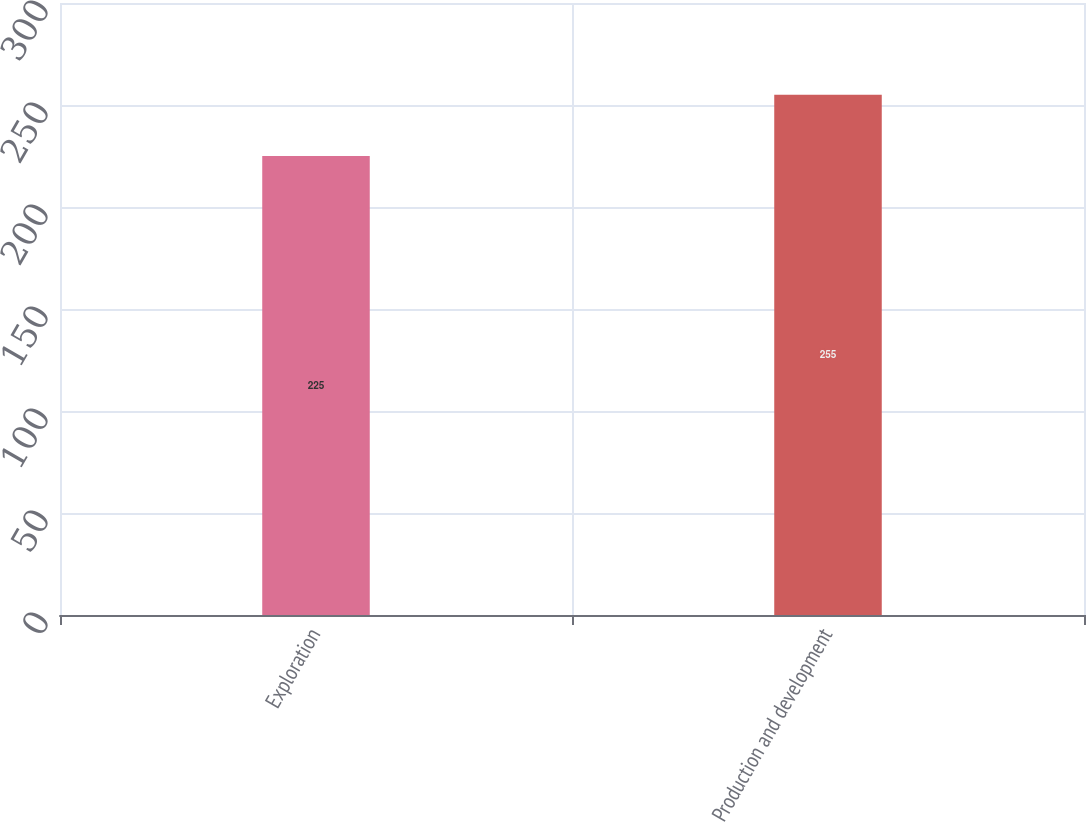Convert chart to OTSL. <chart><loc_0><loc_0><loc_500><loc_500><bar_chart><fcel>Exploration<fcel>Production and development<nl><fcel>225<fcel>255<nl></chart> 